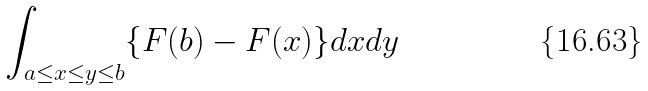Convert formula to latex. <formula><loc_0><loc_0><loc_500><loc_500>\int _ { a \leq x \leq y \leq b } \{ F ( b ) - F ( x ) \} d x d y</formula> 